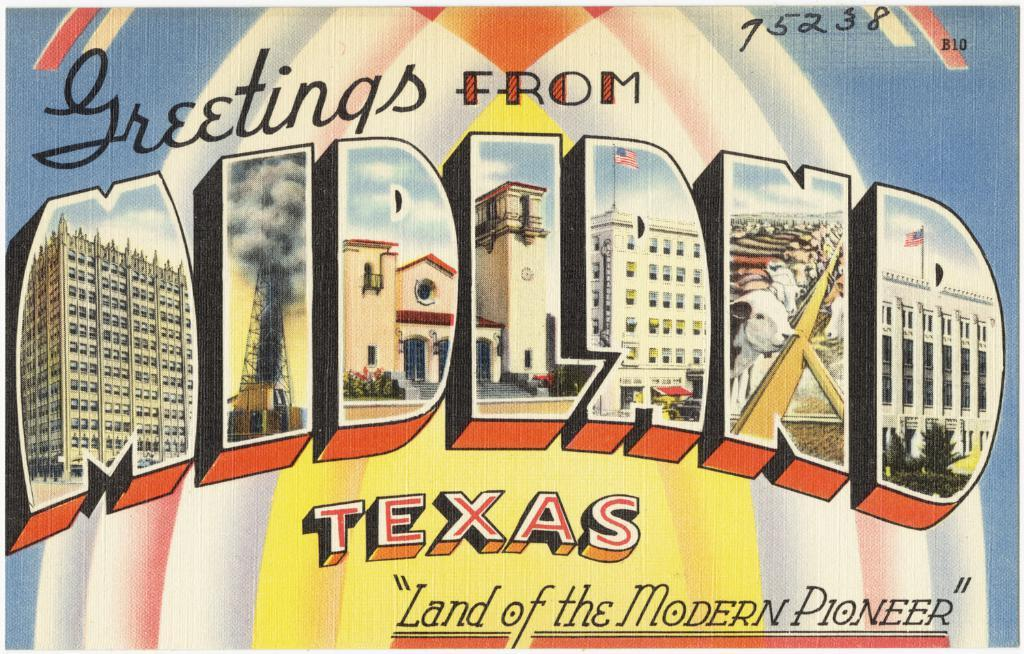<image>
Share a concise interpretation of the image provided. A postcard has the word Midland with pictures in side the letters on it. 